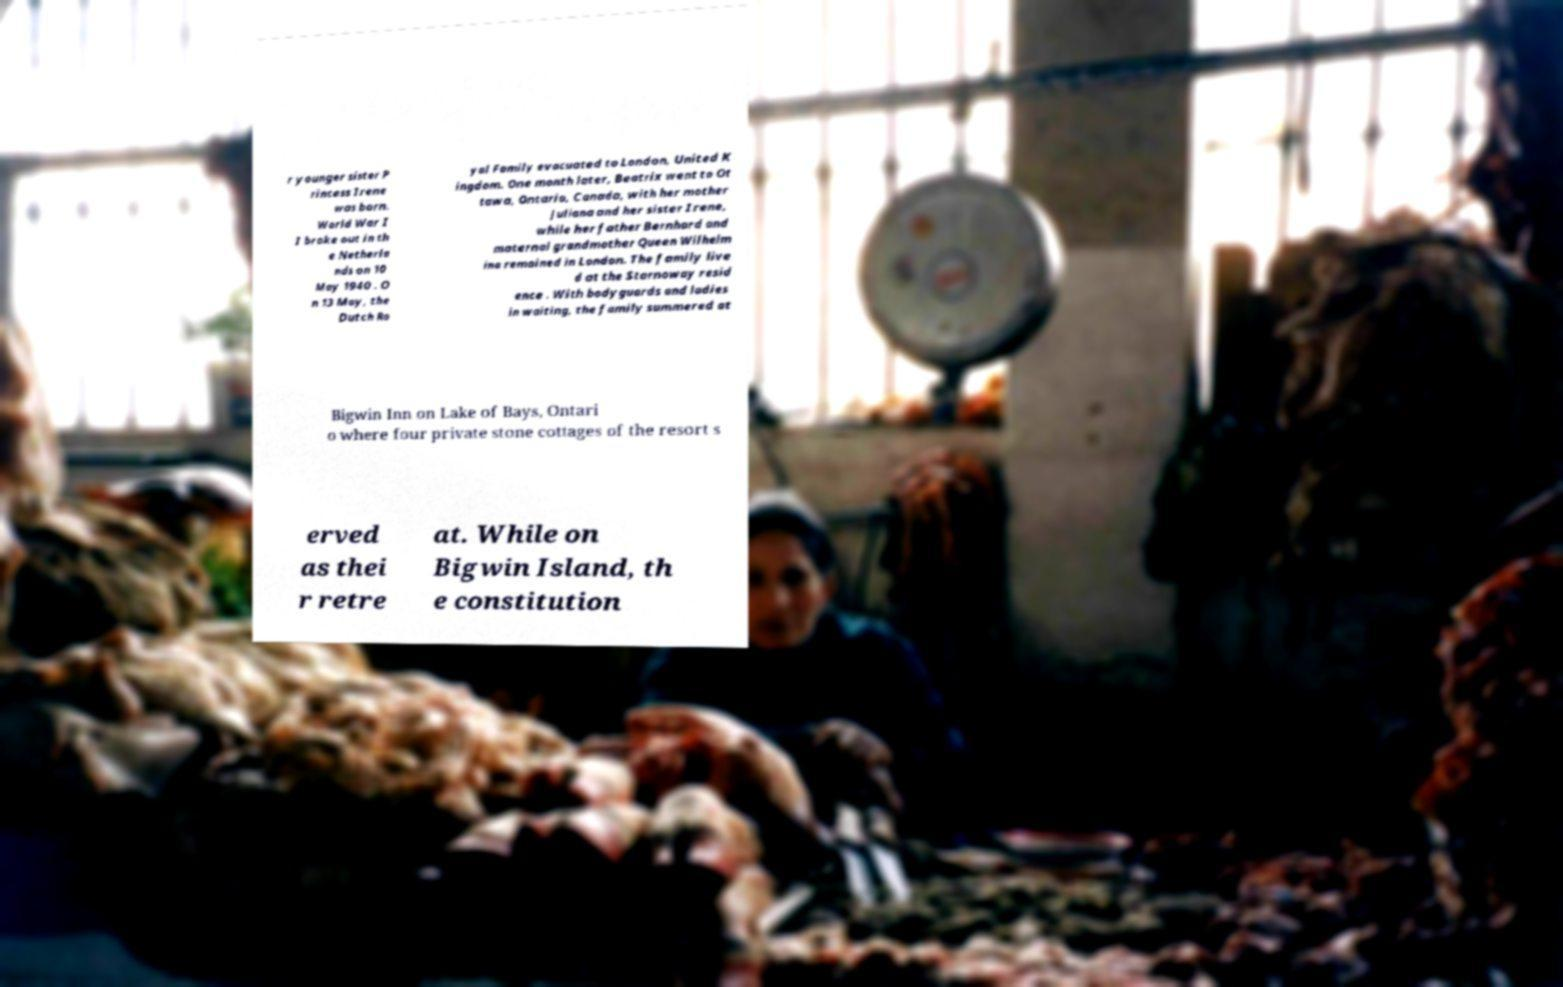Please read and relay the text visible in this image. What does it say? r younger sister P rincess Irene was born. World War I I broke out in th e Netherla nds on 10 May 1940 . O n 13 May, the Dutch Ro yal Family evacuated to London, United K ingdom. One month later, Beatrix went to Ot tawa, Ontario, Canada, with her mother Juliana and her sister Irene, while her father Bernhard and maternal grandmother Queen Wilhelm ina remained in London. The family live d at the Stornoway resid ence . With bodyguards and ladies in waiting, the family summered at Bigwin Inn on Lake of Bays, Ontari o where four private stone cottages of the resort s erved as thei r retre at. While on Bigwin Island, th e constitution 